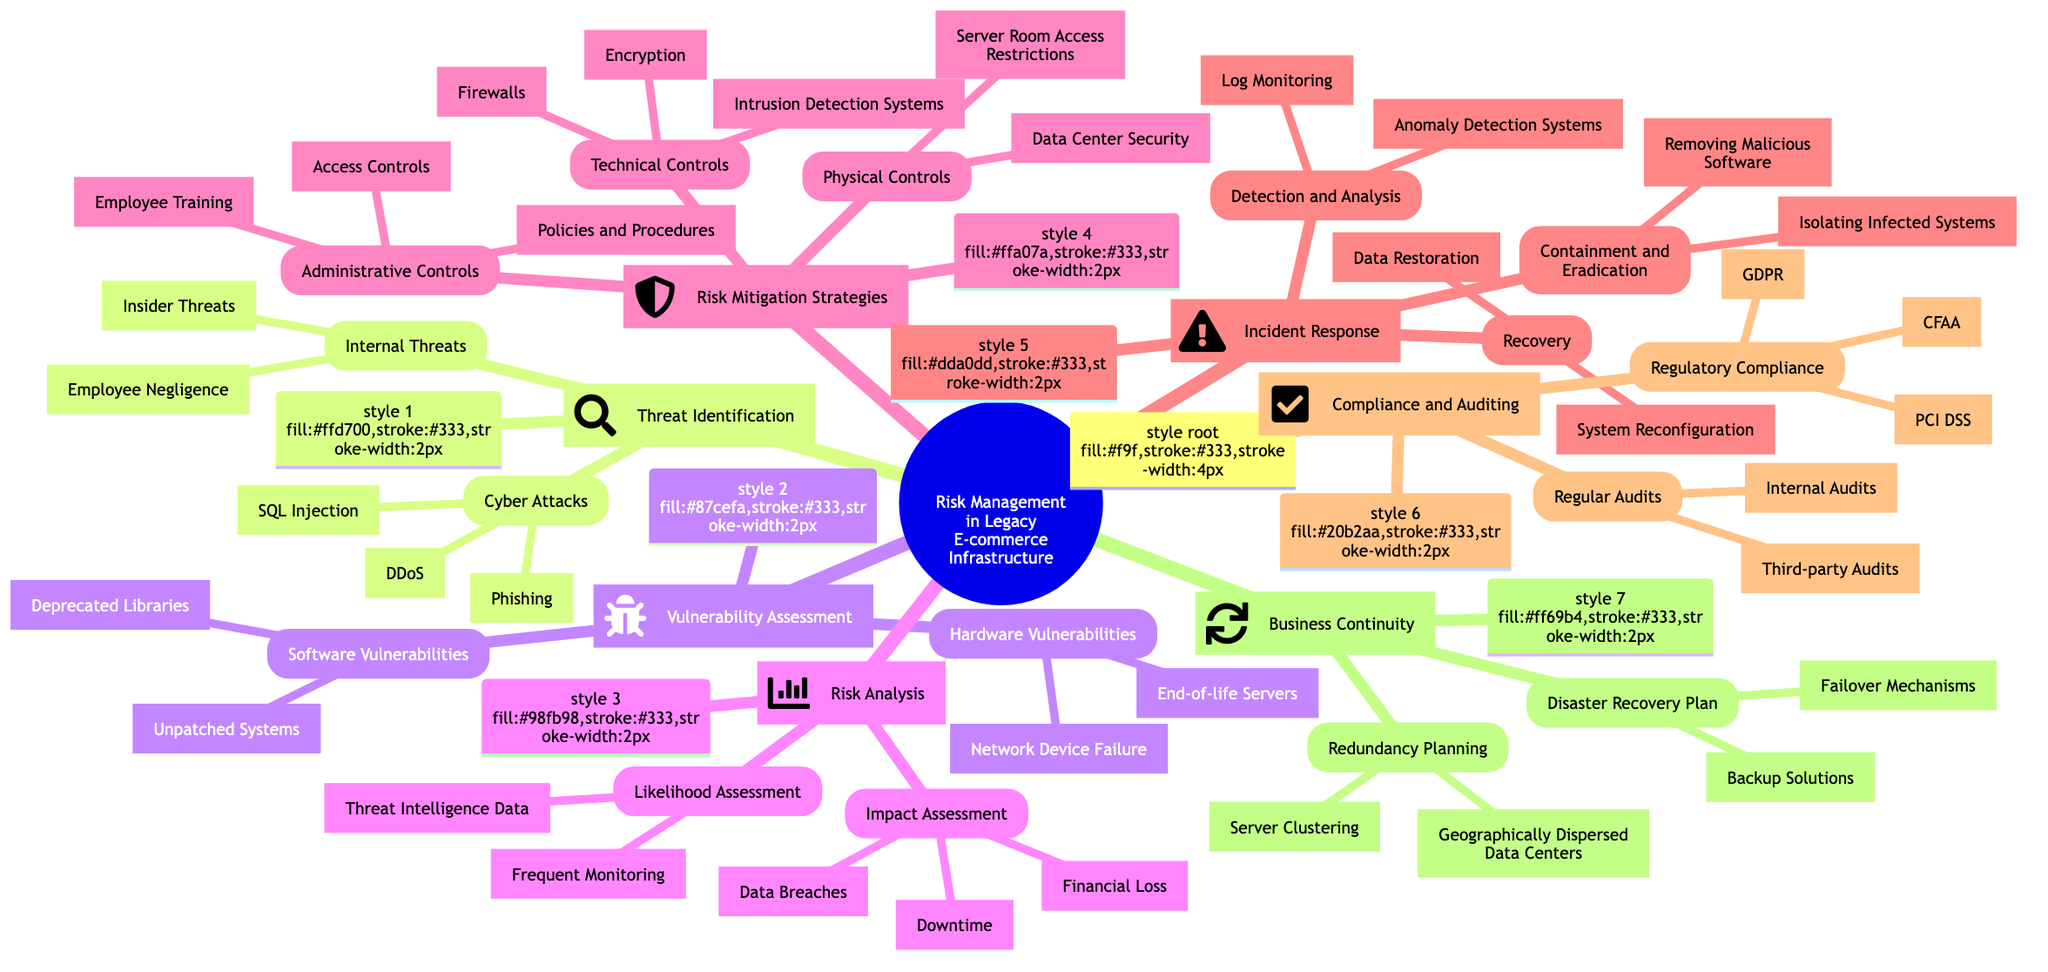What are the two main categories under Threat Identification? The Mind Map clearly shows that the two main categories under Threat Identification are "Cyber Attacks" and "Internal Threats." These categories are listed as the first node and its subnodes.
Answer: Cyber Attacks, Internal Threats How many types of Cyber Attacks are identified? Within the "Cyber Attacks" category, there are three identified types: DDoS, SQL Injection, and Phishing. This information is directly visible as subnodes under the "Cyber Attacks" node.
Answer: 3 What are the components of Risk Mitigation Strategies? The Risk Mitigation Strategies include three components: "Technical Controls," "Administrative Controls," and "Physical Controls." These components can be found as the subnodes of the Risk Mitigation Strategies node in the diagram.
Answer: Technical Controls, Administrative Controls, Physical Controls Which compliance regulations are mentioned under Compliance and Auditing? The regulations specified under Compliance and Auditing are PCI DSS, GDPR, and CFAA. This list is presented as subnodes under the Regulatory Compliance node, making it straightforward to reference.
Answer: PCI DSS, GDPR, CFAA Which incident response strategy involves log monitoring? The strategy that involves log monitoring falls under the "Detection and Analysis" component of Incident Response. The subnode clearly indicates this relationship, allowing for direct identification.
Answer: Detection and Analysis How many vulnerabilities are listed under Software Vulnerabilities? The diagram indicates that there are two vulnerabilities under Software Vulnerabilities: Unpatched Systems and Deprecated Libraries. These vulnerabilities are easy to count as they are distinctly listed under the Software Vulnerabilities node.
Answer: 2 What is a method for Disaster Recovery Plan indicated in the mind map? The Disaster Recovery Plan mentions "Backup Solutions" as one of its methods. This is observable from the hierarchy of nodes under the "Disaster Recovery Plan" node, which lists several solutions directly related to disaster recovery.
Answer: Backup Solutions How are Regular Audits categorized in the diagram? Regular Audits are categorized as a subnode under "Compliance and Auditing," which shows that they are part of the compliance strategy for the e-commerce infrastructure risk management. This can be traced through the nodes easily.
Answer: Regular Audits What does the Recovery step involve in Incident Response? The Recovery step in Incident Response involves "Data Restoration" and "System Reconfiguration." These actions are specified as subnodes under the Recovery node, making them directly identifiable.
Answer: Data Restoration, System Reconfiguration 